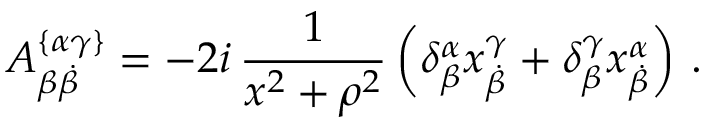Convert formula to latex. <formula><loc_0><loc_0><loc_500><loc_500>A _ { \beta \dot { \beta } } ^ { \{ \alpha \gamma \} } = - 2 i \, \frac { 1 } { x ^ { 2 } + \rho ^ { 2 } } \left ( \delta _ { \beta } ^ { \alpha } x _ { \dot { \beta } } ^ { \gamma } + \delta _ { \beta } ^ { \gamma } x _ { \dot { \beta } } ^ { \alpha } \right ) \, .</formula> 